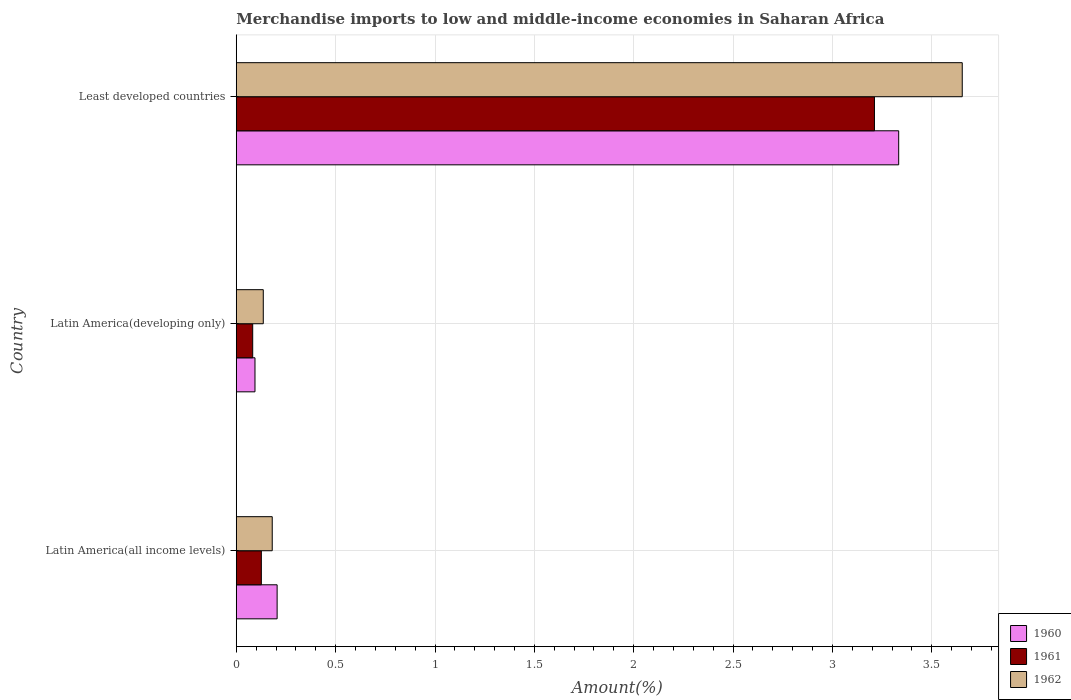How many groups of bars are there?
Your response must be concise. 3. What is the label of the 2nd group of bars from the top?
Keep it short and to the point. Latin America(developing only). What is the percentage of amount earned from merchandise imports in 1961 in Least developed countries?
Your answer should be very brief. 3.21. Across all countries, what is the maximum percentage of amount earned from merchandise imports in 1960?
Provide a short and direct response. 3.33. Across all countries, what is the minimum percentage of amount earned from merchandise imports in 1961?
Make the answer very short. 0.08. In which country was the percentage of amount earned from merchandise imports in 1961 maximum?
Give a very brief answer. Least developed countries. In which country was the percentage of amount earned from merchandise imports in 1962 minimum?
Your response must be concise. Latin America(developing only). What is the total percentage of amount earned from merchandise imports in 1960 in the graph?
Provide a succinct answer. 3.63. What is the difference between the percentage of amount earned from merchandise imports in 1962 in Latin America(all income levels) and that in Least developed countries?
Ensure brevity in your answer.  -3.47. What is the difference between the percentage of amount earned from merchandise imports in 1960 in Latin America(all income levels) and the percentage of amount earned from merchandise imports in 1962 in Latin America(developing only)?
Provide a succinct answer. 0.07. What is the average percentage of amount earned from merchandise imports in 1962 per country?
Offer a very short reply. 1.32. What is the difference between the percentage of amount earned from merchandise imports in 1960 and percentage of amount earned from merchandise imports in 1961 in Latin America(all income levels)?
Provide a succinct answer. 0.08. What is the ratio of the percentage of amount earned from merchandise imports in 1960 in Latin America(all income levels) to that in Least developed countries?
Make the answer very short. 0.06. Is the percentage of amount earned from merchandise imports in 1960 in Latin America(all income levels) less than that in Latin America(developing only)?
Your answer should be very brief. No. Is the difference between the percentage of amount earned from merchandise imports in 1960 in Latin America(developing only) and Least developed countries greater than the difference between the percentage of amount earned from merchandise imports in 1961 in Latin America(developing only) and Least developed countries?
Offer a terse response. No. What is the difference between the highest and the second highest percentage of amount earned from merchandise imports in 1961?
Your response must be concise. 3.08. What is the difference between the highest and the lowest percentage of amount earned from merchandise imports in 1960?
Your answer should be very brief. 3.24. Is the sum of the percentage of amount earned from merchandise imports in 1961 in Latin America(all income levels) and Latin America(developing only) greater than the maximum percentage of amount earned from merchandise imports in 1962 across all countries?
Your answer should be compact. No. What does the 2nd bar from the bottom in Latin America(all income levels) represents?
Provide a short and direct response. 1961. Is it the case that in every country, the sum of the percentage of amount earned from merchandise imports in 1961 and percentage of amount earned from merchandise imports in 1962 is greater than the percentage of amount earned from merchandise imports in 1960?
Your answer should be compact. Yes. How many bars are there?
Give a very brief answer. 9. Are all the bars in the graph horizontal?
Ensure brevity in your answer.  Yes. How many countries are there in the graph?
Your answer should be compact. 3. Are the values on the major ticks of X-axis written in scientific E-notation?
Provide a succinct answer. No. Does the graph contain any zero values?
Offer a very short reply. No. Where does the legend appear in the graph?
Your answer should be very brief. Bottom right. How many legend labels are there?
Your answer should be compact. 3. How are the legend labels stacked?
Your answer should be very brief. Vertical. What is the title of the graph?
Ensure brevity in your answer.  Merchandise imports to low and middle-income economies in Saharan Africa. Does "1979" appear as one of the legend labels in the graph?
Make the answer very short. No. What is the label or title of the X-axis?
Keep it short and to the point. Amount(%). What is the Amount(%) in 1960 in Latin America(all income levels)?
Give a very brief answer. 0.21. What is the Amount(%) in 1961 in Latin America(all income levels)?
Provide a short and direct response. 0.13. What is the Amount(%) in 1962 in Latin America(all income levels)?
Give a very brief answer. 0.18. What is the Amount(%) in 1960 in Latin America(developing only)?
Your answer should be compact. 0.09. What is the Amount(%) of 1961 in Latin America(developing only)?
Your answer should be compact. 0.08. What is the Amount(%) in 1962 in Latin America(developing only)?
Your answer should be very brief. 0.14. What is the Amount(%) in 1960 in Least developed countries?
Keep it short and to the point. 3.33. What is the Amount(%) in 1961 in Least developed countries?
Your response must be concise. 3.21. What is the Amount(%) in 1962 in Least developed countries?
Your response must be concise. 3.65. Across all countries, what is the maximum Amount(%) in 1960?
Provide a short and direct response. 3.33. Across all countries, what is the maximum Amount(%) of 1961?
Your response must be concise. 3.21. Across all countries, what is the maximum Amount(%) in 1962?
Make the answer very short. 3.65. Across all countries, what is the minimum Amount(%) in 1960?
Provide a short and direct response. 0.09. Across all countries, what is the minimum Amount(%) of 1961?
Provide a succinct answer. 0.08. Across all countries, what is the minimum Amount(%) in 1962?
Your response must be concise. 0.14. What is the total Amount(%) of 1960 in the graph?
Make the answer very short. 3.63. What is the total Amount(%) of 1961 in the graph?
Give a very brief answer. 3.42. What is the total Amount(%) of 1962 in the graph?
Your answer should be compact. 3.97. What is the difference between the Amount(%) in 1960 in Latin America(all income levels) and that in Latin America(developing only)?
Keep it short and to the point. 0.11. What is the difference between the Amount(%) in 1961 in Latin America(all income levels) and that in Latin America(developing only)?
Provide a succinct answer. 0.04. What is the difference between the Amount(%) in 1962 in Latin America(all income levels) and that in Latin America(developing only)?
Your response must be concise. 0.05. What is the difference between the Amount(%) in 1960 in Latin America(all income levels) and that in Least developed countries?
Keep it short and to the point. -3.13. What is the difference between the Amount(%) of 1961 in Latin America(all income levels) and that in Least developed countries?
Provide a short and direct response. -3.08. What is the difference between the Amount(%) in 1962 in Latin America(all income levels) and that in Least developed countries?
Offer a very short reply. -3.47. What is the difference between the Amount(%) in 1960 in Latin America(developing only) and that in Least developed countries?
Offer a very short reply. -3.24. What is the difference between the Amount(%) in 1961 in Latin America(developing only) and that in Least developed countries?
Your answer should be compact. -3.13. What is the difference between the Amount(%) of 1962 in Latin America(developing only) and that in Least developed countries?
Offer a terse response. -3.52. What is the difference between the Amount(%) in 1960 in Latin America(all income levels) and the Amount(%) in 1961 in Latin America(developing only)?
Offer a very short reply. 0.12. What is the difference between the Amount(%) in 1960 in Latin America(all income levels) and the Amount(%) in 1962 in Latin America(developing only)?
Make the answer very short. 0.07. What is the difference between the Amount(%) of 1961 in Latin America(all income levels) and the Amount(%) of 1962 in Latin America(developing only)?
Your answer should be very brief. -0.01. What is the difference between the Amount(%) of 1960 in Latin America(all income levels) and the Amount(%) of 1961 in Least developed countries?
Give a very brief answer. -3.01. What is the difference between the Amount(%) of 1960 in Latin America(all income levels) and the Amount(%) of 1962 in Least developed countries?
Offer a very short reply. -3.45. What is the difference between the Amount(%) in 1961 in Latin America(all income levels) and the Amount(%) in 1962 in Least developed countries?
Offer a very short reply. -3.53. What is the difference between the Amount(%) in 1960 in Latin America(developing only) and the Amount(%) in 1961 in Least developed countries?
Your response must be concise. -3.12. What is the difference between the Amount(%) of 1960 in Latin America(developing only) and the Amount(%) of 1962 in Least developed countries?
Make the answer very short. -3.56. What is the difference between the Amount(%) in 1961 in Latin America(developing only) and the Amount(%) in 1962 in Least developed countries?
Ensure brevity in your answer.  -3.57. What is the average Amount(%) in 1960 per country?
Keep it short and to the point. 1.21. What is the average Amount(%) in 1961 per country?
Your response must be concise. 1.14. What is the average Amount(%) of 1962 per country?
Provide a short and direct response. 1.32. What is the difference between the Amount(%) in 1960 and Amount(%) in 1961 in Latin America(all income levels)?
Your answer should be very brief. 0.08. What is the difference between the Amount(%) of 1960 and Amount(%) of 1962 in Latin America(all income levels)?
Ensure brevity in your answer.  0.02. What is the difference between the Amount(%) in 1961 and Amount(%) in 1962 in Latin America(all income levels)?
Provide a short and direct response. -0.05. What is the difference between the Amount(%) in 1960 and Amount(%) in 1961 in Latin America(developing only)?
Ensure brevity in your answer.  0.01. What is the difference between the Amount(%) in 1960 and Amount(%) in 1962 in Latin America(developing only)?
Give a very brief answer. -0.04. What is the difference between the Amount(%) of 1961 and Amount(%) of 1962 in Latin America(developing only)?
Ensure brevity in your answer.  -0.05. What is the difference between the Amount(%) of 1960 and Amount(%) of 1961 in Least developed countries?
Offer a very short reply. 0.12. What is the difference between the Amount(%) in 1960 and Amount(%) in 1962 in Least developed countries?
Ensure brevity in your answer.  -0.32. What is the difference between the Amount(%) of 1961 and Amount(%) of 1962 in Least developed countries?
Ensure brevity in your answer.  -0.44. What is the ratio of the Amount(%) of 1960 in Latin America(all income levels) to that in Latin America(developing only)?
Your answer should be compact. 2.18. What is the ratio of the Amount(%) of 1961 in Latin America(all income levels) to that in Latin America(developing only)?
Keep it short and to the point. 1.53. What is the ratio of the Amount(%) in 1962 in Latin America(all income levels) to that in Latin America(developing only)?
Ensure brevity in your answer.  1.33. What is the ratio of the Amount(%) of 1960 in Latin America(all income levels) to that in Least developed countries?
Offer a terse response. 0.06. What is the ratio of the Amount(%) of 1961 in Latin America(all income levels) to that in Least developed countries?
Offer a very short reply. 0.04. What is the ratio of the Amount(%) of 1962 in Latin America(all income levels) to that in Least developed countries?
Give a very brief answer. 0.05. What is the ratio of the Amount(%) in 1960 in Latin America(developing only) to that in Least developed countries?
Your response must be concise. 0.03. What is the ratio of the Amount(%) of 1961 in Latin America(developing only) to that in Least developed countries?
Offer a terse response. 0.03. What is the ratio of the Amount(%) in 1962 in Latin America(developing only) to that in Least developed countries?
Provide a short and direct response. 0.04. What is the difference between the highest and the second highest Amount(%) of 1960?
Ensure brevity in your answer.  3.13. What is the difference between the highest and the second highest Amount(%) in 1961?
Provide a succinct answer. 3.08. What is the difference between the highest and the second highest Amount(%) in 1962?
Your response must be concise. 3.47. What is the difference between the highest and the lowest Amount(%) in 1960?
Provide a succinct answer. 3.24. What is the difference between the highest and the lowest Amount(%) of 1961?
Offer a very short reply. 3.13. What is the difference between the highest and the lowest Amount(%) of 1962?
Ensure brevity in your answer.  3.52. 